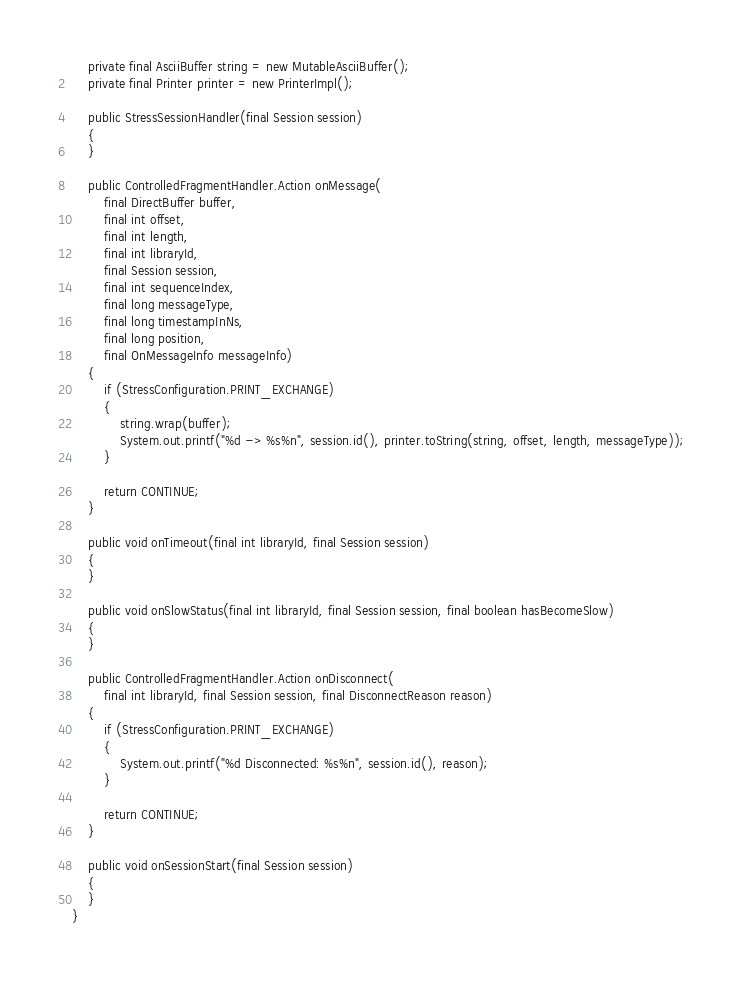<code> <loc_0><loc_0><loc_500><loc_500><_Java_>    private final AsciiBuffer string = new MutableAsciiBuffer();
    private final Printer printer = new PrinterImpl();

    public StressSessionHandler(final Session session)
    {
    }

    public ControlledFragmentHandler.Action onMessage(
        final DirectBuffer buffer,
        final int offset,
        final int length,
        final int libraryId,
        final Session session,
        final int sequenceIndex,
        final long messageType,
        final long timestampInNs,
        final long position,
        final OnMessageInfo messageInfo)
    {
        if (StressConfiguration.PRINT_EXCHANGE)
        {
            string.wrap(buffer);
            System.out.printf("%d -> %s%n", session.id(), printer.toString(string, offset, length, messageType));
        }

        return CONTINUE;
    }

    public void onTimeout(final int libraryId, final Session session)
    {
    }

    public void onSlowStatus(final int libraryId, final Session session, final boolean hasBecomeSlow)
    {
    }

    public ControlledFragmentHandler.Action onDisconnect(
        final int libraryId, final Session session, final DisconnectReason reason)
    {
        if (StressConfiguration.PRINT_EXCHANGE)
        {
            System.out.printf("%d Disconnected: %s%n", session.id(), reason);
        }

        return CONTINUE;
    }

    public void onSessionStart(final Session session)
    {
    }
}
</code> 